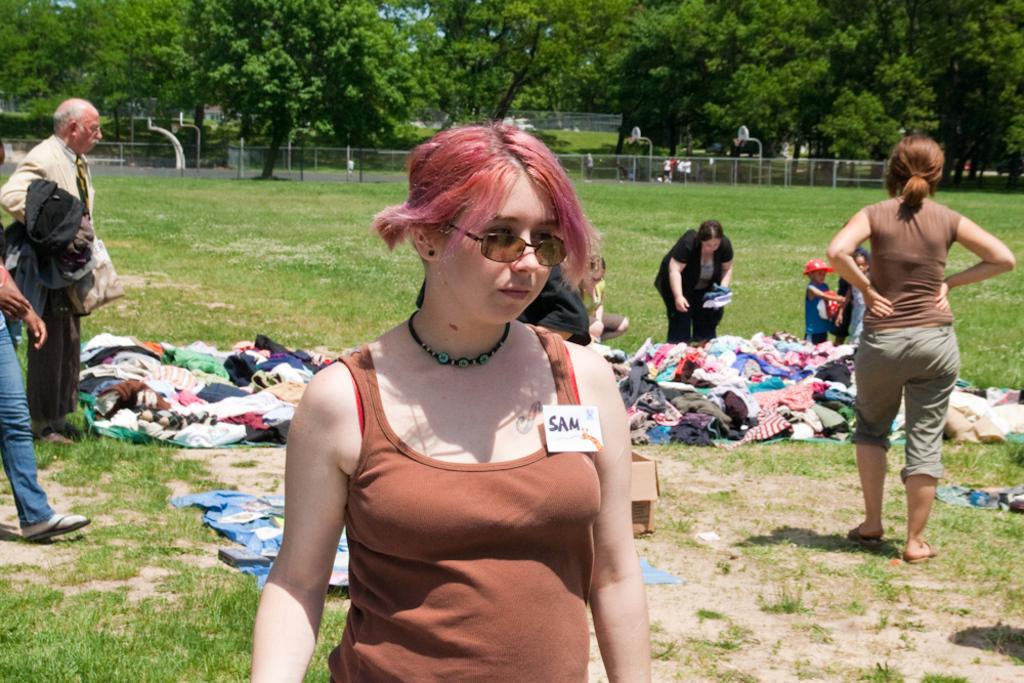Can you describe this image briefly? In this picture, we can see a few people, among them a few are holding some objects, we can see the ground with grass, and some objects like clothes, and we can see fencing, basket ball goal court, trees, and the sky. 